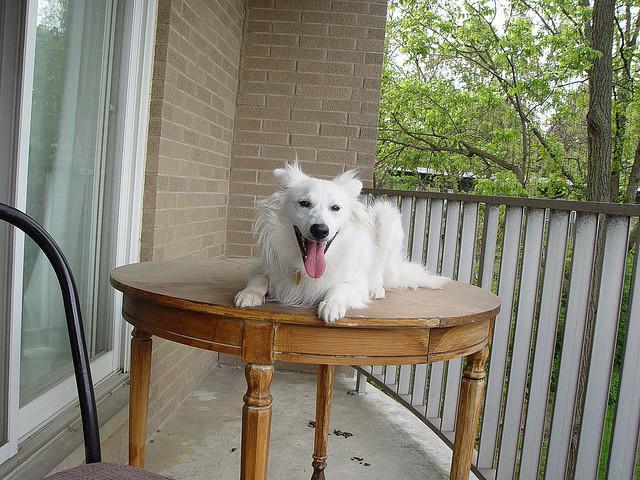Is the dog happy on the table?
Be succinct. Yes. Can you see the dog's tongue?
Be succinct. Yes. Is the dog wearing a collar?
Concise answer only. Yes. 